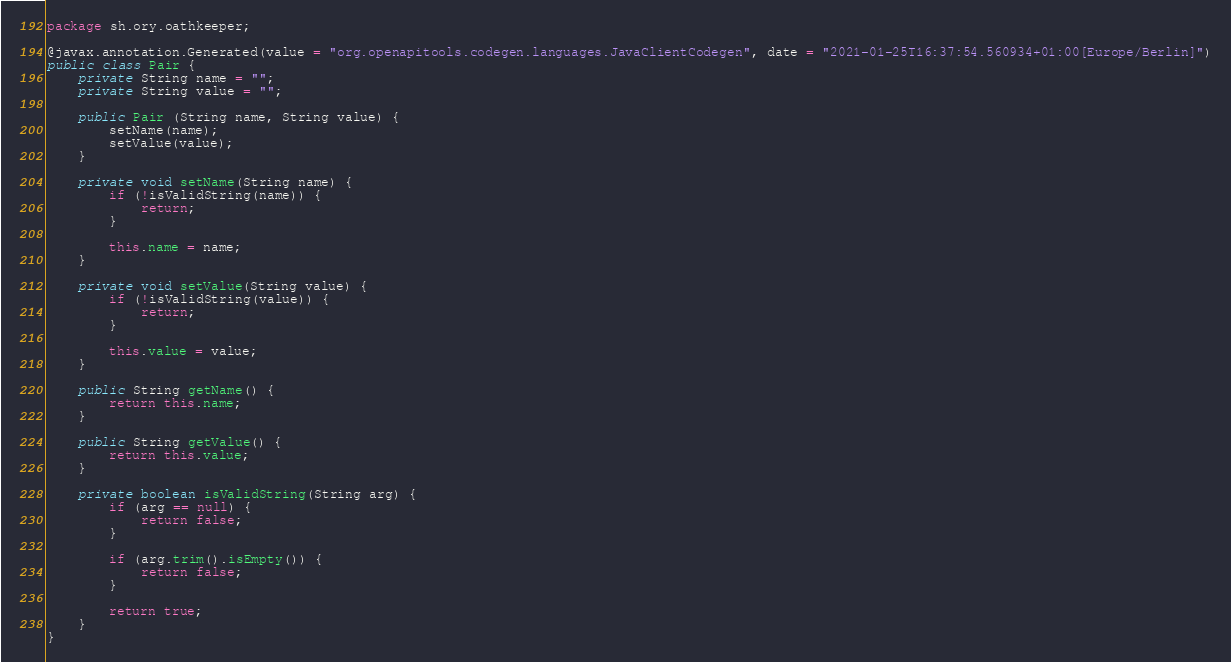Convert code to text. <code><loc_0><loc_0><loc_500><loc_500><_Java_>
package sh.ory.oathkeeper;

@javax.annotation.Generated(value = "org.openapitools.codegen.languages.JavaClientCodegen", date = "2021-01-25T16:37:54.560934+01:00[Europe/Berlin]")
public class Pair {
    private String name = "";
    private String value = "";

    public Pair (String name, String value) {
        setName(name);
        setValue(value);
    }

    private void setName(String name) {
        if (!isValidString(name)) {
            return;
        }

        this.name = name;
    }

    private void setValue(String value) {
        if (!isValidString(value)) {
            return;
        }

        this.value = value;
    }

    public String getName() {
        return this.name;
    }

    public String getValue() {
        return this.value;
    }

    private boolean isValidString(String arg) {
        if (arg == null) {
            return false;
        }

        if (arg.trim().isEmpty()) {
            return false;
        }

        return true;
    }
}
</code> 